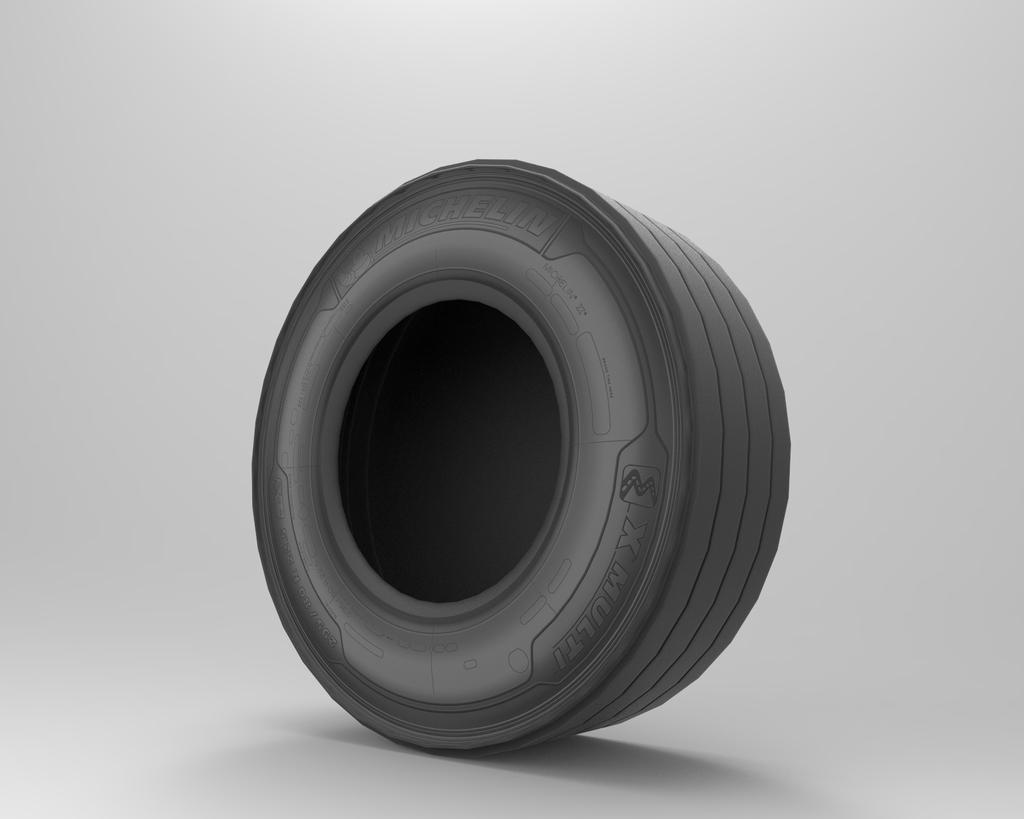What color is the background of the image? The background of the image is white. What object is located in the middle of the image? There is a tire in the middle of the image. What is the color of the tire? The tire is black in color. How many stockings are hanging from the tire in the image? There are no stockings present in the image; it only features a tire. 